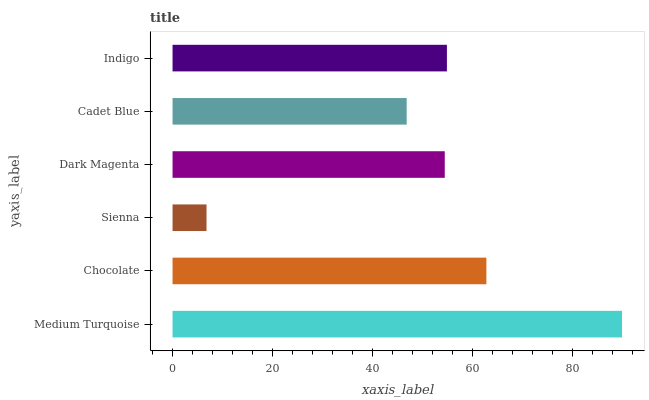Is Sienna the minimum?
Answer yes or no. Yes. Is Medium Turquoise the maximum?
Answer yes or no. Yes. Is Chocolate the minimum?
Answer yes or no. No. Is Chocolate the maximum?
Answer yes or no. No. Is Medium Turquoise greater than Chocolate?
Answer yes or no. Yes. Is Chocolate less than Medium Turquoise?
Answer yes or no. Yes. Is Chocolate greater than Medium Turquoise?
Answer yes or no. No. Is Medium Turquoise less than Chocolate?
Answer yes or no. No. Is Indigo the high median?
Answer yes or no. Yes. Is Dark Magenta the low median?
Answer yes or no. Yes. Is Cadet Blue the high median?
Answer yes or no. No. Is Chocolate the low median?
Answer yes or no. No. 